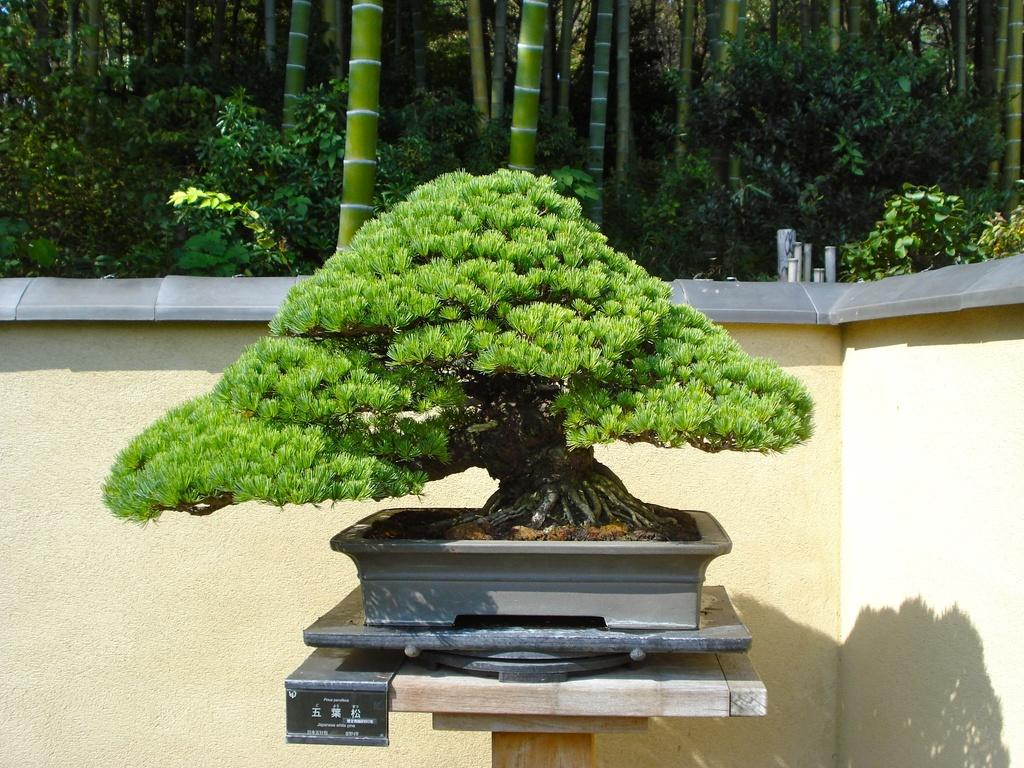What object is present in the image that holds a plant? There is a plant pot in the image. Where is the plant pot located? The plant pot is placed on a table. Can you describe the plant in the pot? The plant in the pot appears to be artificial. What can be seen in the background of the image? There is a wall visible in the background of the image. What type of vegetation is visible at the top of the image? Trees are present at the top of the image. What type of crown is worn by the rice in the image? There is no rice or crown present in the image. 